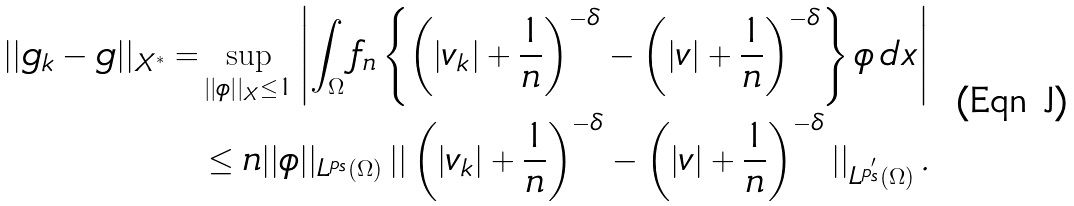Convert formula to latex. <formula><loc_0><loc_0><loc_500><loc_500>| | g _ { k } - g | | _ { X ^ { * } } = & \sup _ { | | \phi | | _ { X } \leq 1 } \left | \int _ { \Omega } { f _ { n } } \left \{ { \left ( | v _ { k } | + \frac { 1 } { n } \right ) ^ { - \delta } } - { \left ( | v | + \frac { 1 } { n } \right ) ^ { - \delta } } \right \} \phi \, d x \right | \\ & \leq n | | \phi | | _ { L ^ { p _ { s } } ( \Omega ) } \left | \right | { \left ( | v _ { k } | + \frac { 1 } { n } \right ) ^ { - \delta } } - { \left ( | v | + \frac { 1 } { n } \right ) ^ { - \delta } } \left | \right | _ { L ^ { p _ { s } ^ { ^ { \prime } } } ( \Omega ) } .</formula> 